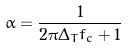<formula> <loc_0><loc_0><loc_500><loc_500>\alpha = \frac { 1 } { 2 \pi \Delta _ { T } f _ { c } + 1 }</formula> 